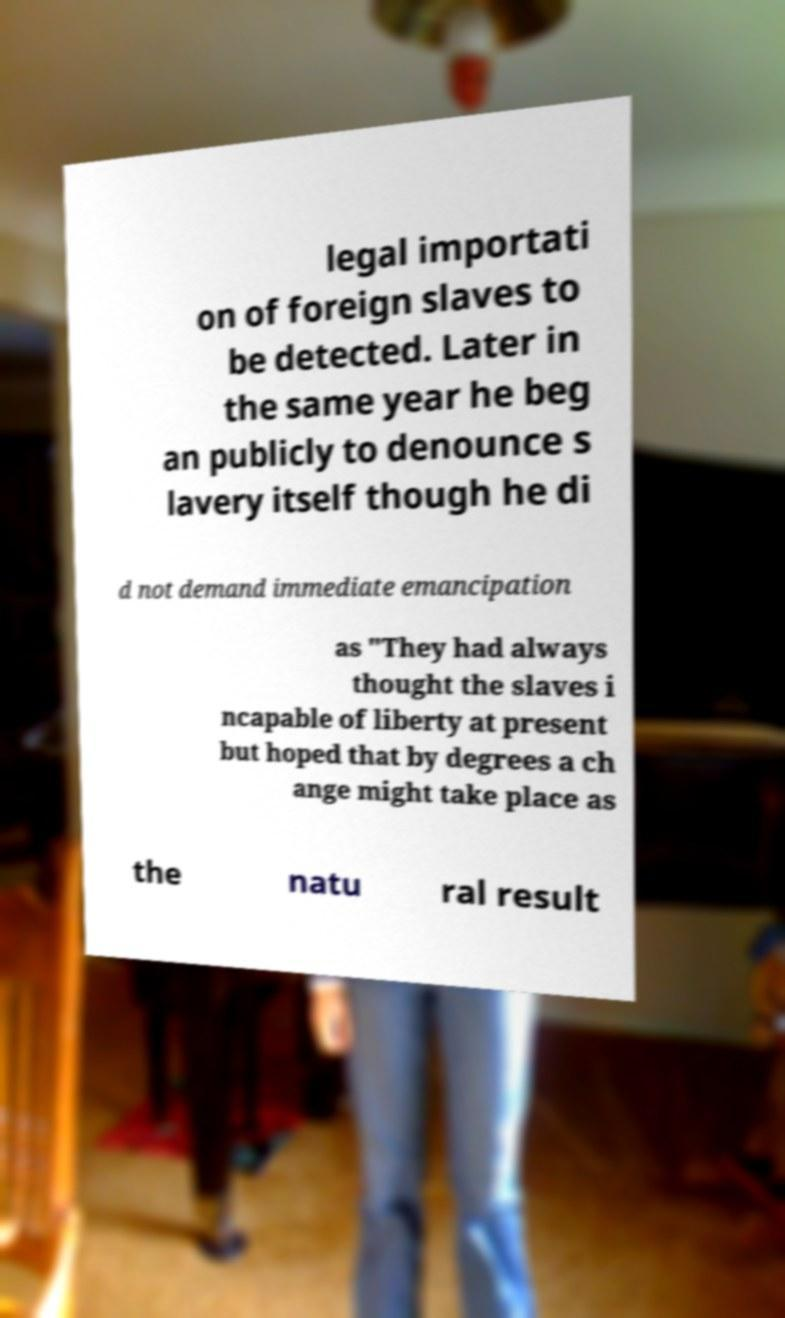What messages or text are displayed in this image? I need them in a readable, typed format. legal importati on of foreign slaves to be detected. Later in the same year he beg an publicly to denounce s lavery itself though he di d not demand immediate emancipation as "They had always thought the slaves i ncapable of liberty at present but hoped that by degrees a ch ange might take place as the natu ral result 